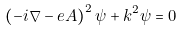<formula> <loc_0><loc_0><loc_500><loc_500>\left ( - i \nabla - e A \right ) ^ { 2 } \psi + k ^ { 2 } \psi = 0</formula> 